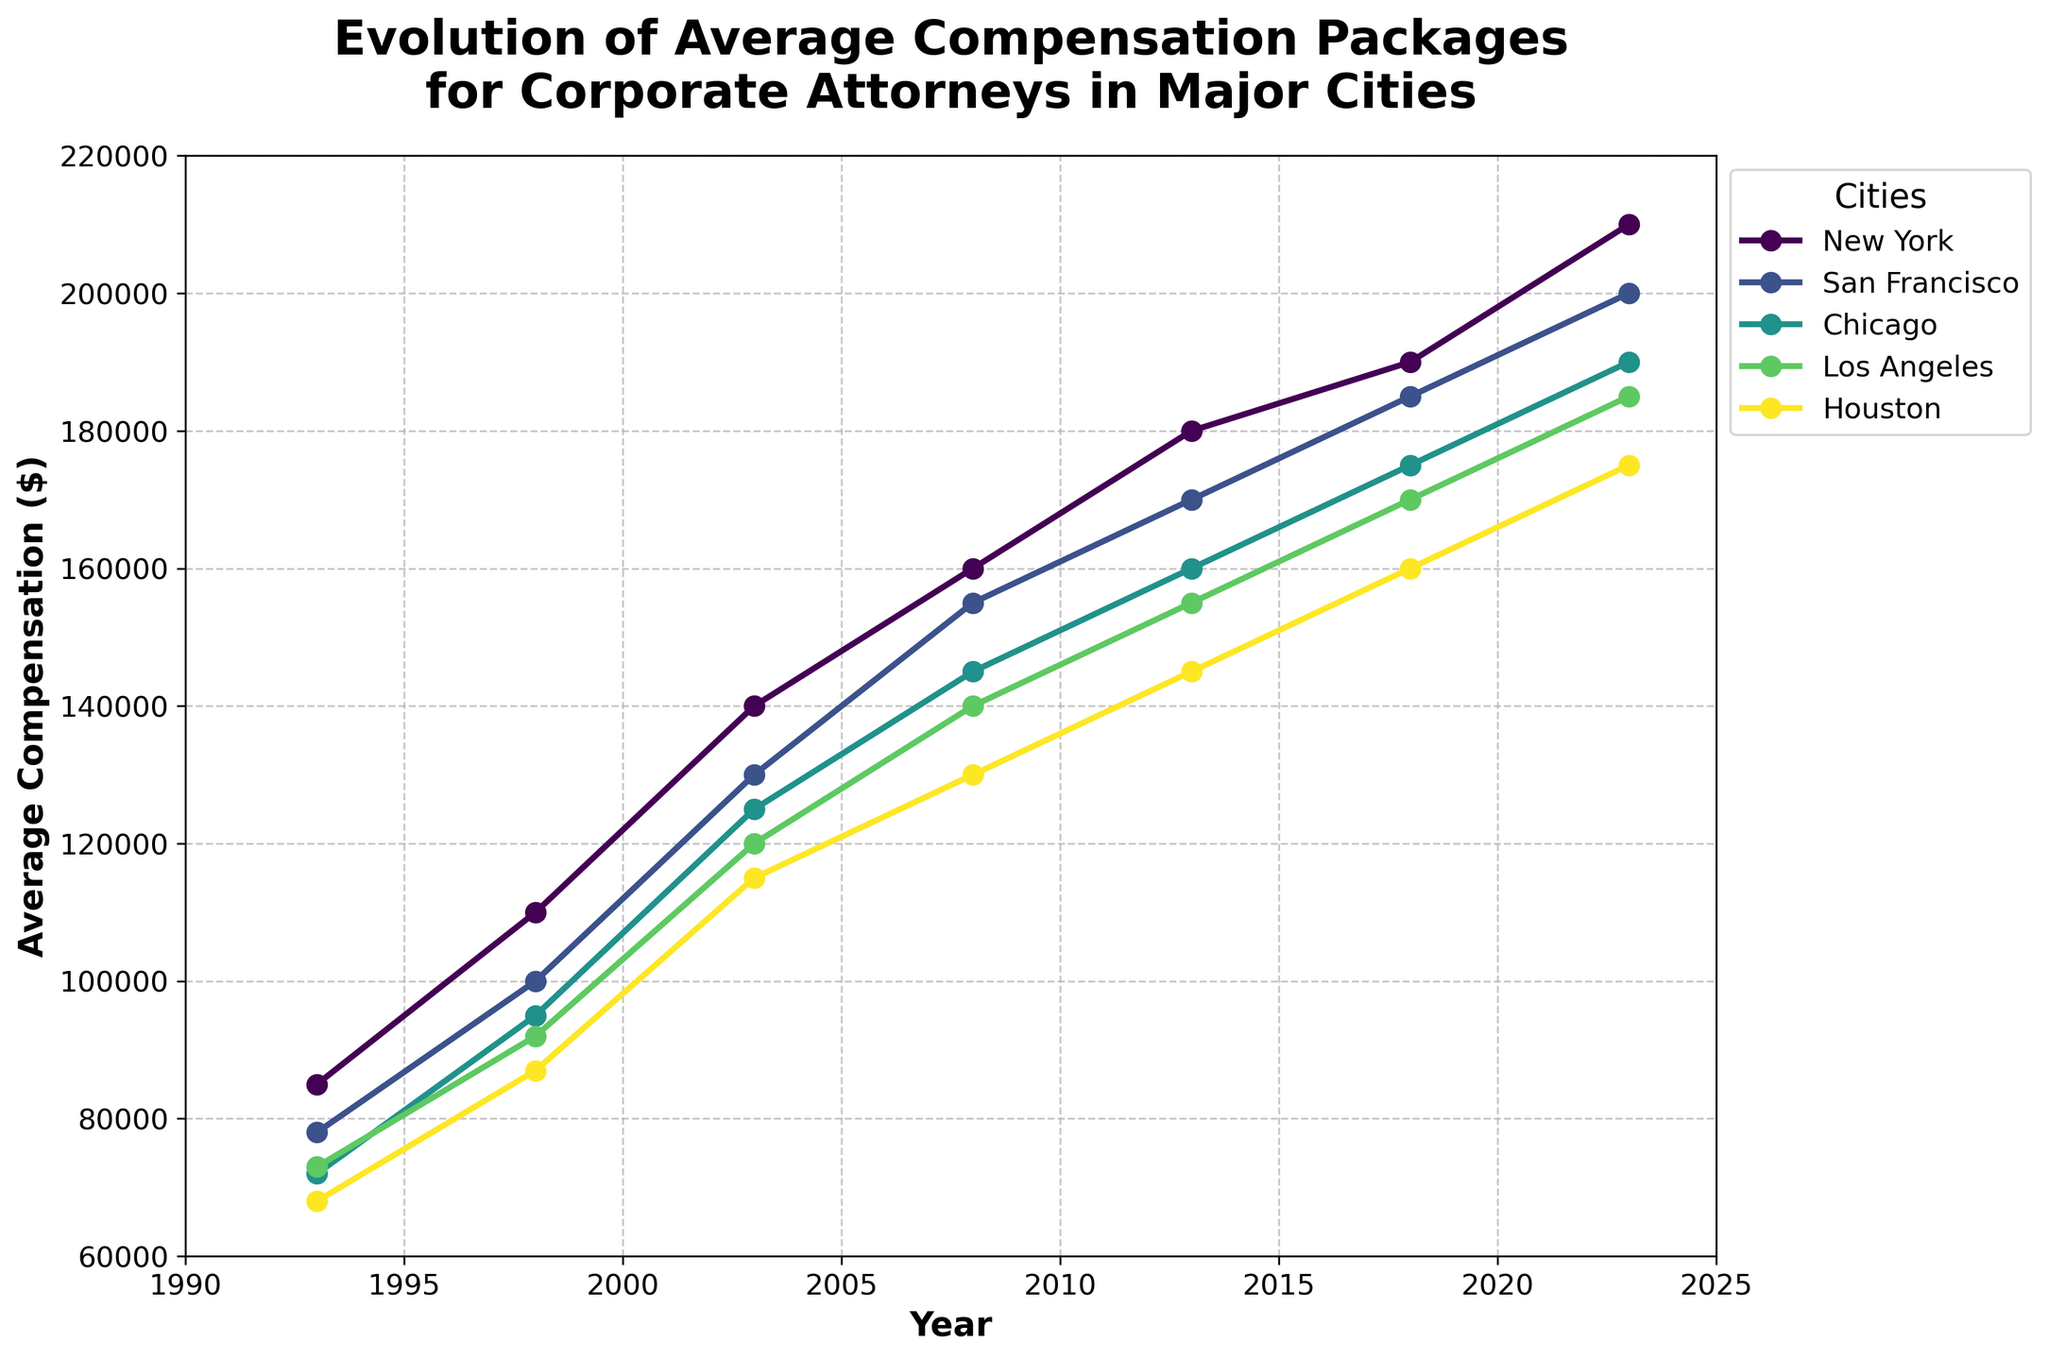What is the title of the figure? The title of the figure is located at the top and reads "Evolution of Average Compensation Packages for Corporate Attorneys in Major Cities."
Answer: Evolution of Average Compensation Packages for Corporate Attorneys in Major Cities Which city had the highest average compensation in 1993? By looking at the data points for 1993, New York has the highest average compensation among the cities.
Answer: New York In 2023, how much higher is the average compensation in New York compared to Houston? The average compensation in New York in 2023 is $210,000, whereas in Houston, it is $175,000. The difference is $210,000 - $175,000 = $35,000.
Answer: $35,000 Which city experienced the greatest increase in average compensation from 1993 to 2023? By calculating the increase for each city from 1993 to 2023: New York ($210,000 - $85,000 = $125,000), San Francisco ($200,000 - $78,000 = $122,000), Chicago ($190,000 - $72,000 = $118,000), Los Angeles ($185,000 - $73,000 = $112,000), Houston ($175,000 - $68,000 = $107,000). New York has the greatest increase.
Answer: New York What is the total increase in average compensation for San Francisco over the entire period? By calculating the increase for each time interval and summing them: (1998 - 1993) $100,000 - $78,000 = $22,000, (2003 - 1998) $130,000 - $100,000 = $30,000, (2008 - 2003) $155,000 - $130,000 = $25,000, (2013 - 2008) $170,000 - $155,000 = $15,000, (2018 - 2013) $185,000 - $170,000 = $15,000, (2023 - 2018) $200,000 - $185,000 = $15,000. Total increase is $22,000 + $30,000 + $25,000 + $15,000 + $15,000 + $15,000 = $122,000.
Answer: $122,000 In which year did Los Angeles first surpass an average compensation of $150,000? By examining the data points for Los Angeles, the first year it had an average compensation above $150,000 was 2013, with $155,000.
Answer: 2013 When comparing 2013 to 2003, which city saw the smallest increase in average compensation? By calculating the increase for each city from 2003 to 2013: New York ($180,000 - $140,000 = $40,000), San Francisco ($170,000 - $130,000 = $40,000), Chicago ($160,000 - $125,000 = $35,000), Los Angeles ($155,000 - $120,000 = $35,000), Houston ($145,000 - $115,000 = $30,000). Houston had the smallest increase.
Answer: Houston Which city had the closest average compensation to $120,000 in 2008? By looking at the data points for 2008, Los Angeles had an average compensation of $140,000, which is the closest to $120,000 among the cities.
Answer: Los Angeles From 1998 to 2018, how many times did the average compensation in Chicago increase by at least $15,000? By checking each interval for Chicago: (2003 - 1998) $125,000 - $95,000 = $30,000 (1st), (2008 - 2003) $145,000 - $125,000 = $20,000 (2nd), (2013 - 2008) $160,000 - $145,000 = $15,000 (3rd), (2018 - 2013) $175,000 - $160,000 = $15,000 (4th). It increased by at least $15,000 four times.
Answer: Four times 